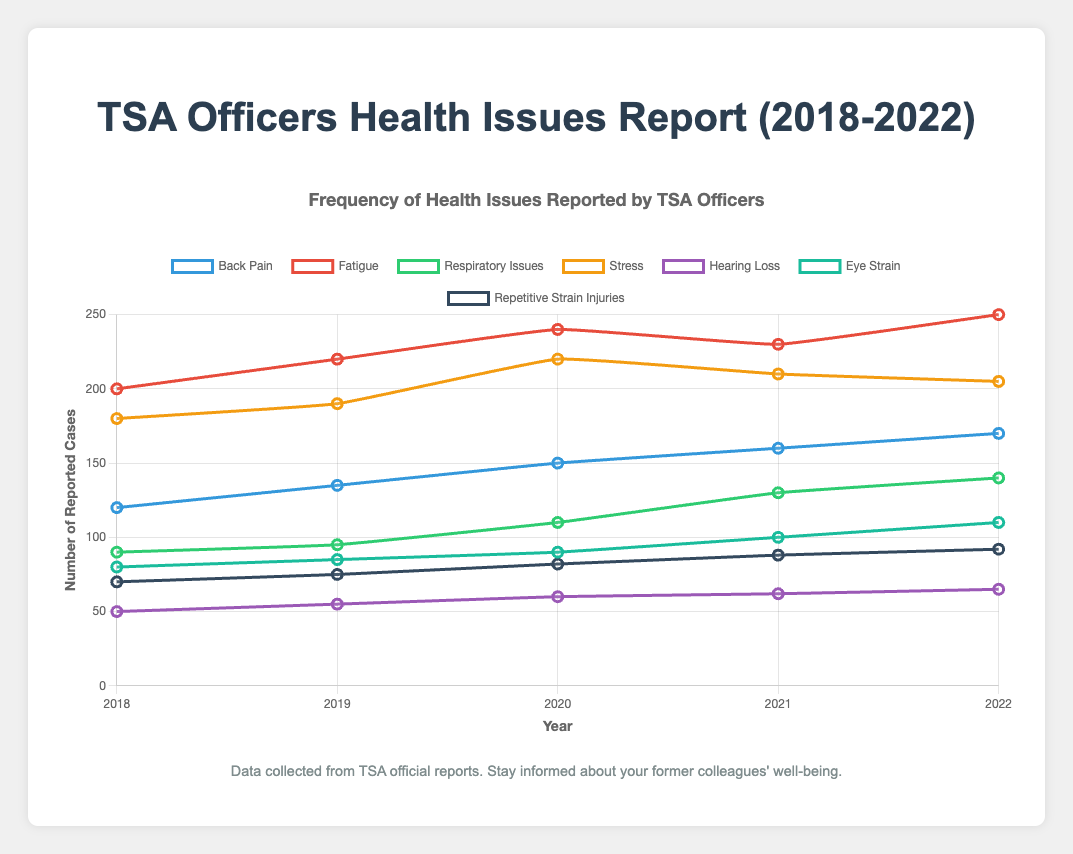Which health issue had the highest number of reported cases in 2022? Looking at the data for 2022, the health issue with the highest value is Fatigue with 250 reported cases.
Answer: Fatigue How many more cases of Back Pain were reported in 2022 compared to 2018? The number of reported cases of Back Pain in 2018 was 120, and in 2022 it was 170. The difference is 170 - 120 = 50.
Answer: 50 Which health issues saw an increase in reported cases every year from 2018 to 2022? By examining each health issue's values across the years:
- Back Pain increased every year.
- Fatigue increased every year except 2021.
- Respiratory Issues increased every year.
- Stress increased till 2020, then decreased.
- Hearing Loss increased every year.
- Eye Strain increased every year.
- Repetitive Strain Injuries increased every year.
So, Back Pain, Respiratory Issues, Hearing Loss, Eye Strain, and Repetitive Strain Injuries increased every year.
Answer: Back Pain, Respiratory Issues, Hearing Loss, Eye Strain, Repetitive Strain Injuries Between which consecutive years did Eye Strain see the largest increase in reported cases? Looking at the Eye Strain data, the increase between consecutive years is:
- 2018 to 2019: 85 - 80 = 5
- 2019 to 2020: 90 - 85 = 5
- 2020 to 2021: 100 - 90 = 10
- 2021 to 2022: 110 - 100 = 10
The largest increase occurred between 2020 to 2021 and 2021 to 2022, both with an increase of 10 cases.
Answer: 2020 to 2021, 2021 to 2022 Which health issue had the smallest number of reported cases throughout the entire period from 2018 to 2022? Looking at the minimum value for each health issue from 2018 to 2022:
- Back Pain: 120
- Fatigue: 200
- Respiratory Issues: 90
- Stress: 180
- Hearing Loss: 50
- Eye Strain: 80
- Repetitive Strain Injuries: 70
The smallest number of reported cases is Hearing Loss with 50 cases.
Answer: Hearing Loss Which two health issues had exactly the same number of reported cases in any given year? Examining the data for all years:
- No two health issues had the exact number of reported cases in any of the years from 2018 to 2022.
Answer: None What is the total number of Stress cases reported from 2018 to 2022? Summing up the values for Stress from each year: 180 + 190 + 220 + 210 + 205 = 1005.
Answer: 1005 